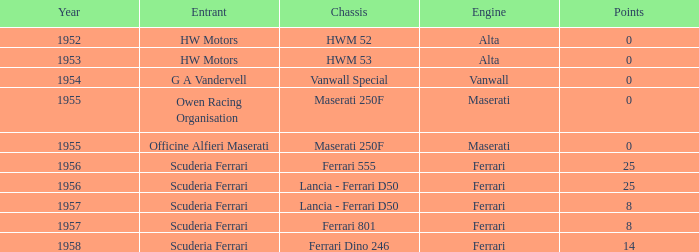What is the maximum points when maserati created the engine, and a member of owen racing organisation? 0.0. 